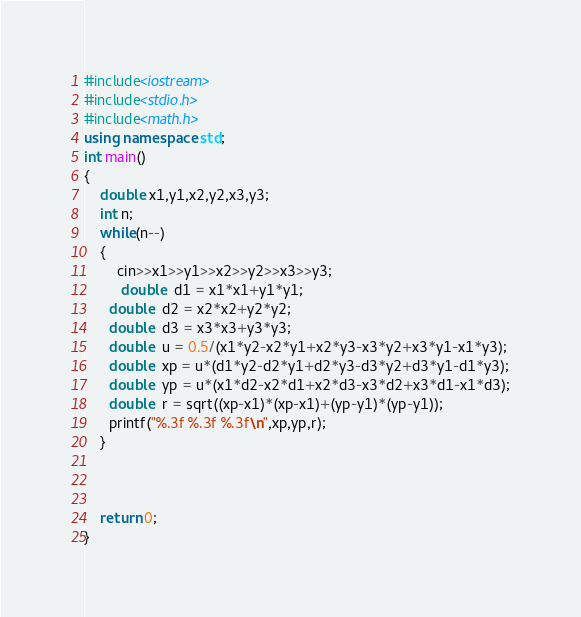Convert code to text. <code><loc_0><loc_0><loc_500><loc_500><_C++_>#include<iostream>
#include<stdio.h>
#include<math.h>
using namespace std;
int main()
{
    double x1,y1,x2,y2,x3,y3;
    int n;
    while(n--)
    {
        cin>>x1>>y1>>x2>>y2>>x3>>y3;
         double  d1 = x1*x1+y1*y1;
      double  d2 = x2*x2+y2*y2;
      double  d3 = x3*x3+y3*y3;
      double  u = 0.5/(x1*y2-x2*y1+x2*y3-x3*y2+x3*y1-x1*y3);
      double  xp = u*(d1*y2-d2*y1+d2*y3-d3*y2+d3*y1-d1*y3);
      double  yp = u*(x1*d2-x2*d1+x2*d3-x3*d2+x3*d1-x1*d3);
      double  r = sqrt((xp-x1)*(xp-x1)+(yp-y1)*(yp-y1));
      printf("%.3f %.3f %.3f\n",xp,yp,r);
    }



    return 0;
}</code> 